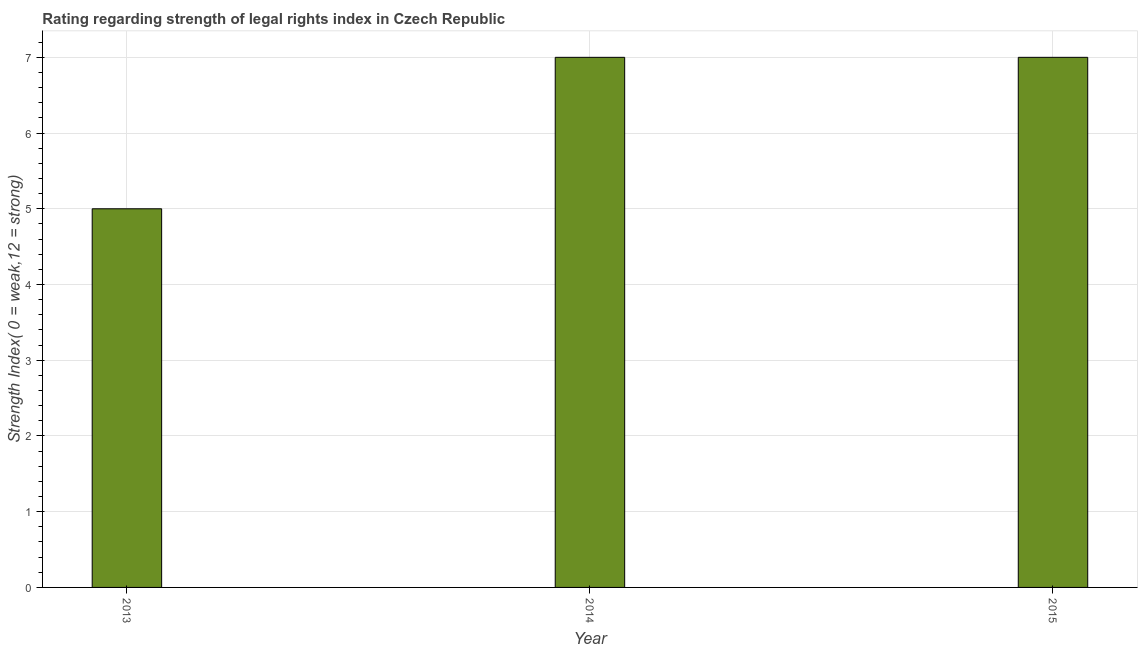Does the graph contain grids?
Your answer should be compact. Yes. What is the title of the graph?
Give a very brief answer. Rating regarding strength of legal rights index in Czech Republic. What is the label or title of the X-axis?
Keep it short and to the point. Year. What is the label or title of the Y-axis?
Your answer should be compact. Strength Index( 0 = weak,12 = strong). What is the strength of legal rights index in 2015?
Your answer should be compact. 7. Across all years, what is the maximum strength of legal rights index?
Your response must be concise. 7. Across all years, what is the minimum strength of legal rights index?
Make the answer very short. 5. What is the difference between the strength of legal rights index in 2014 and 2015?
Make the answer very short. 0. What is the average strength of legal rights index per year?
Your response must be concise. 6. What is the median strength of legal rights index?
Provide a short and direct response. 7. Do a majority of the years between 2015 and 2014 (inclusive) have strength of legal rights index greater than 1.4 ?
Provide a short and direct response. No. What is the ratio of the strength of legal rights index in 2013 to that in 2015?
Provide a succinct answer. 0.71. Is the strength of legal rights index in 2014 less than that in 2015?
Offer a very short reply. No. What is the difference between the highest and the second highest strength of legal rights index?
Provide a succinct answer. 0. Is the sum of the strength of legal rights index in 2013 and 2015 greater than the maximum strength of legal rights index across all years?
Your answer should be very brief. Yes. What is the difference between the highest and the lowest strength of legal rights index?
Your response must be concise. 2. In how many years, is the strength of legal rights index greater than the average strength of legal rights index taken over all years?
Your answer should be compact. 2. How many bars are there?
Your response must be concise. 3. How many years are there in the graph?
Offer a terse response. 3. Are the values on the major ticks of Y-axis written in scientific E-notation?
Your answer should be very brief. No. What is the Strength Index( 0 = weak,12 = strong) of 2014?
Provide a short and direct response. 7. What is the difference between the Strength Index( 0 = weak,12 = strong) in 2013 and 2014?
Offer a very short reply. -2. What is the difference between the Strength Index( 0 = weak,12 = strong) in 2013 and 2015?
Your response must be concise. -2. What is the ratio of the Strength Index( 0 = weak,12 = strong) in 2013 to that in 2014?
Your answer should be compact. 0.71. What is the ratio of the Strength Index( 0 = weak,12 = strong) in 2013 to that in 2015?
Your answer should be very brief. 0.71. 